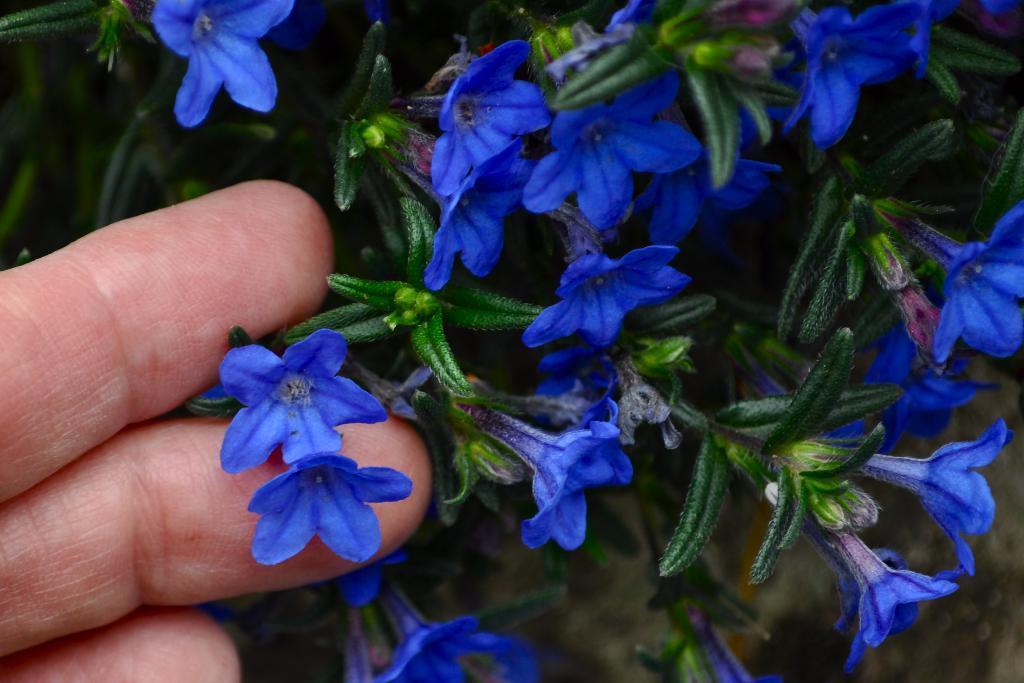In one or two sentences, can you explain what this image depicts? This image is taken outdoors. In this image there is a plant with leaves, stems and flowers. Those flowers are blue in color. On the left side of the image there are three fingers of a person. 